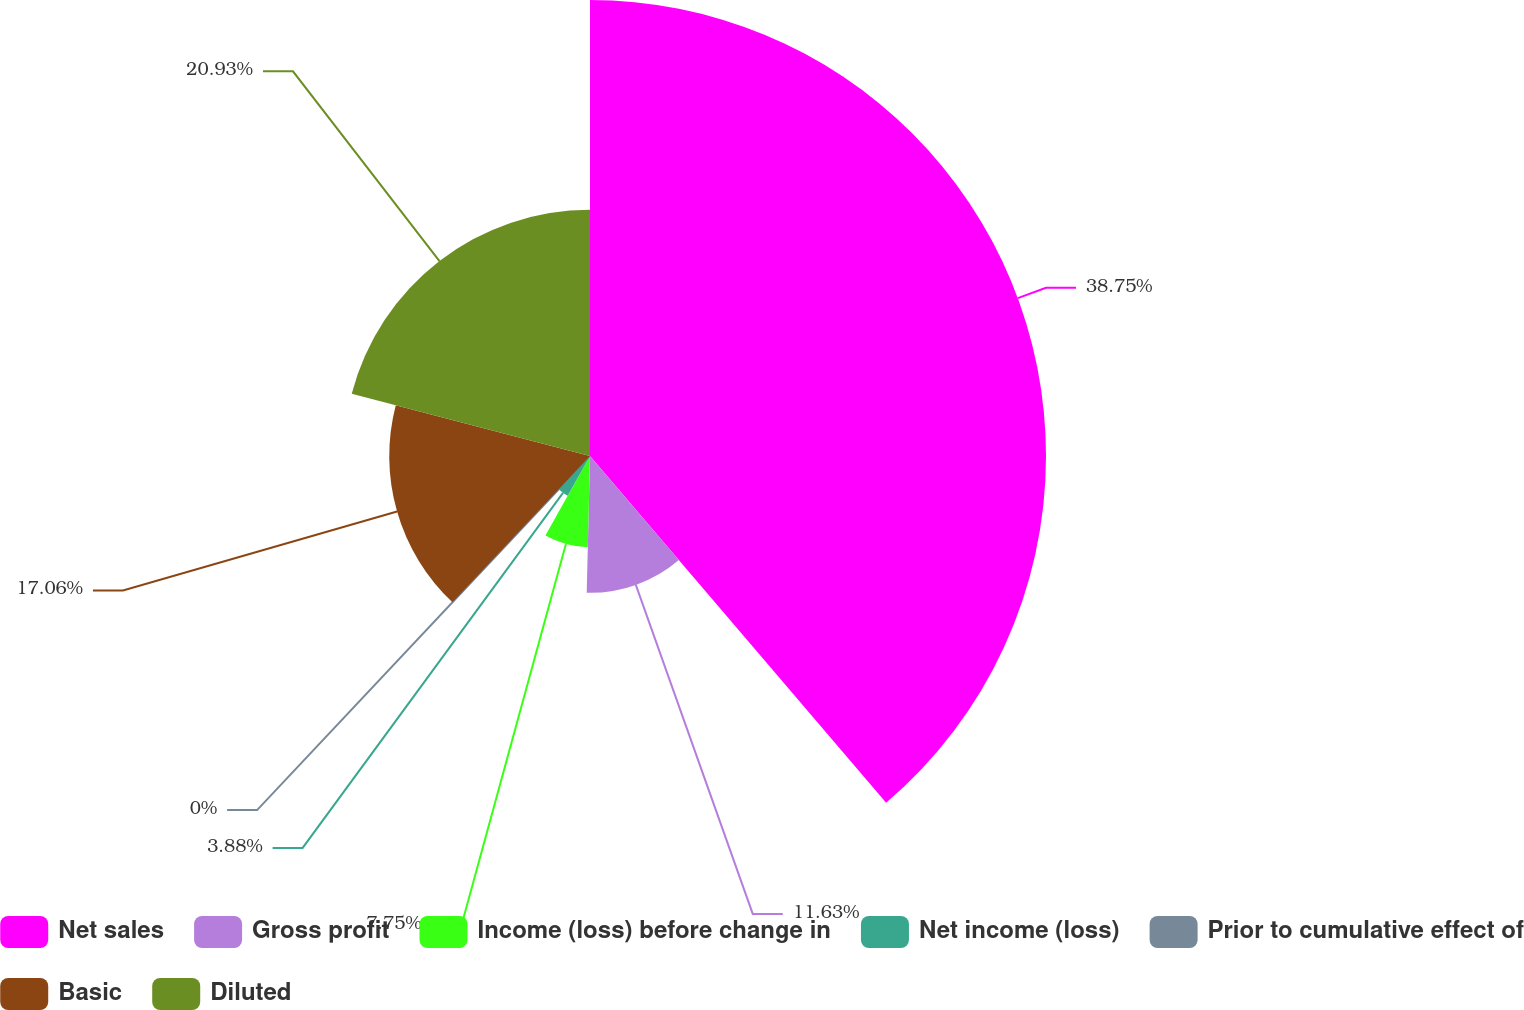Convert chart. <chart><loc_0><loc_0><loc_500><loc_500><pie_chart><fcel>Net sales<fcel>Gross profit<fcel>Income (loss) before change in<fcel>Net income (loss)<fcel>Prior to cumulative effect of<fcel>Basic<fcel>Diluted<nl><fcel>38.75%<fcel>11.63%<fcel>7.75%<fcel>3.88%<fcel>0.0%<fcel>17.06%<fcel>20.93%<nl></chart> 